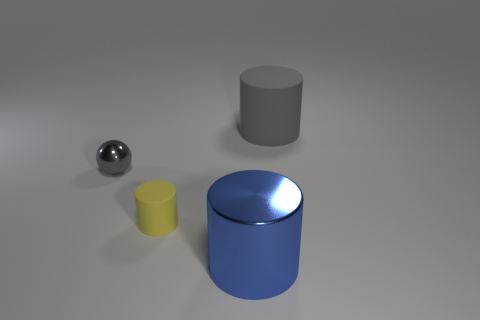Add 2 big brown things. How many objects exist? 6 Subtract all balls. How many objects are left? 3 Subtract 1 blue cylinders. How many objects are left? 3 Subtract all large cyan rubber cylinders. Subtract all gray metal balls. How many objects are left? 3 Add 2 small yellow things. How many small yellow things are left? 3 Add 1 gray cylinders. How many gray cylinders exist? 2 